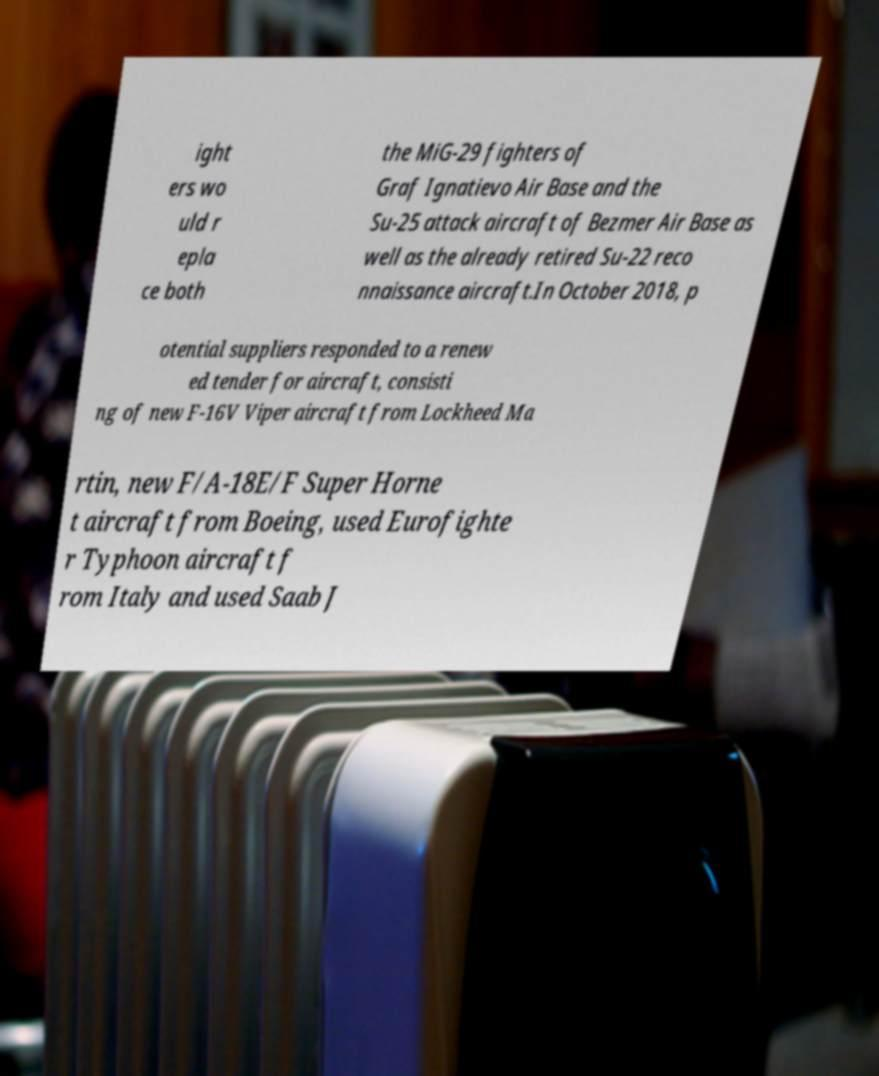What messages or text are displayed in this image? I need them in a readable, typed format. ight ers wo uld r epla ce both the MiG-29 fighters of Graf Ignatievo Air Base and the Su-25 attack aircraft of Bezmer Air Base as well as the already retired Su-22 reco nnaissance aircraft.In October 2018, p otential suppliers responded to a renew ed tender for aircraft, consisti ng of new F-16V Viper aircraft from Lockheed Ma rtin, new F/A-18E/F Super Horne t aircraft from Boeing, used Eurofighte r Typhoon aircraft f rom Italy and used Saab J 